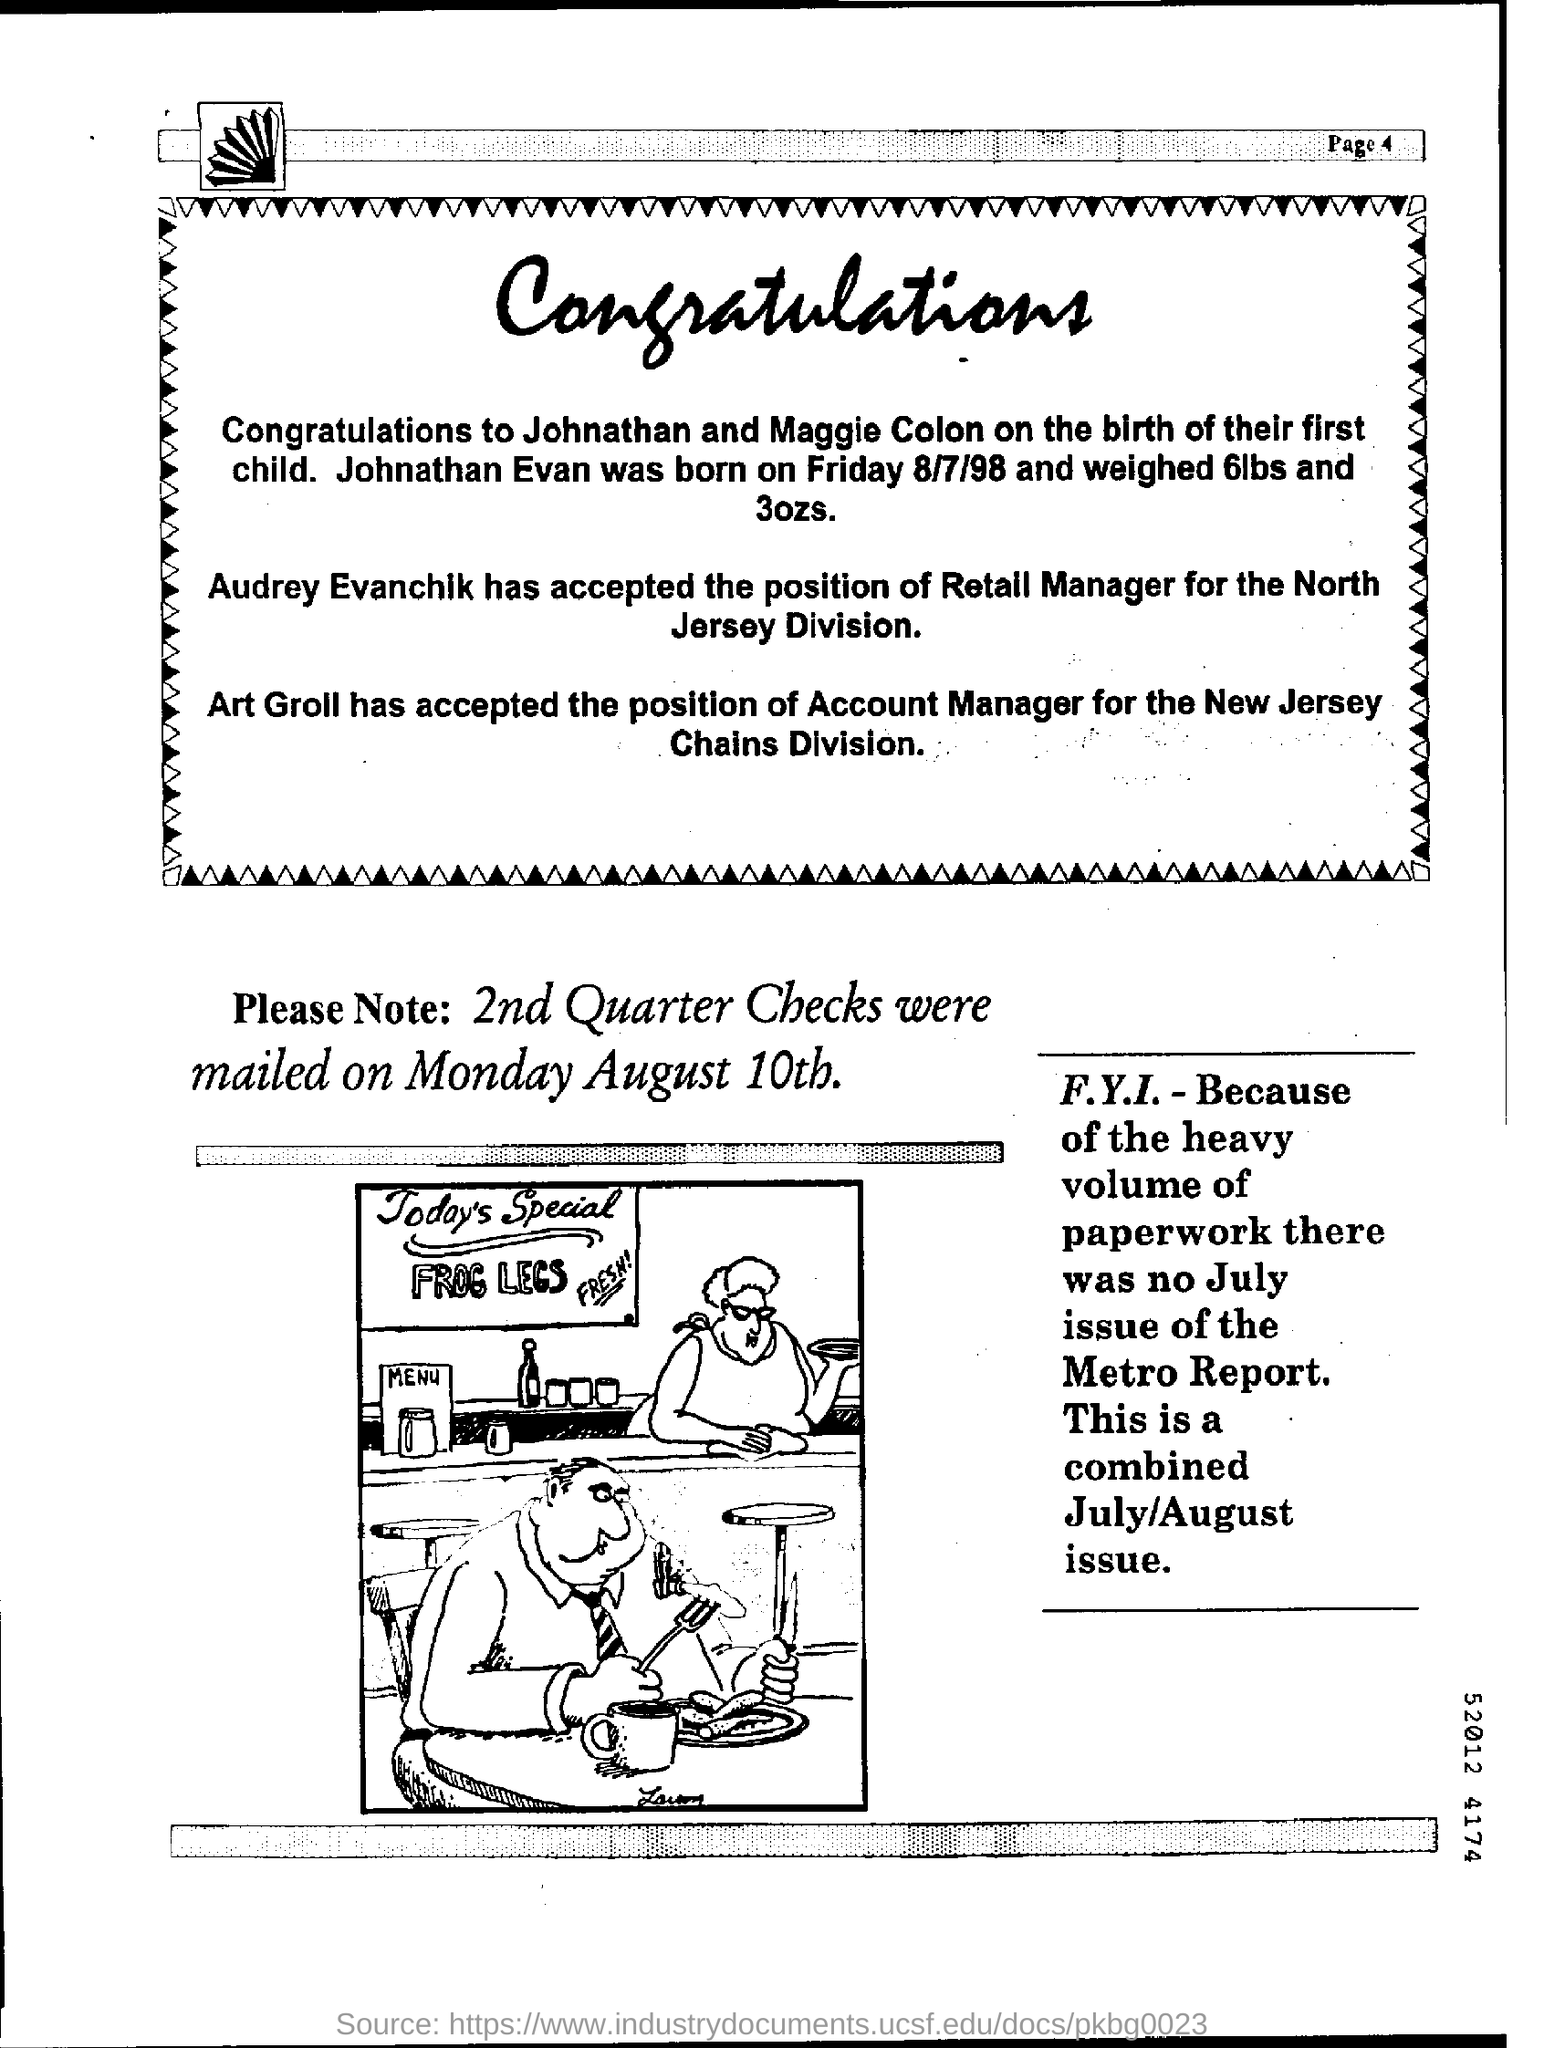WHEN WAS THE 2ND QUARTER CHECKS MAILED?
Provide a succinct answer. MONDAY AUGUST 10th. WHEN WAS JOHNATHAN EVAN BORN?
Give a very brief answer. FRIDAY 8/7/98. HOW MUCH DID JOHNATHAN EVAN WEIGH?
Keep it short and to the point. 6lbs and 3Ozs. WHO ARE THE PARENTS OF JOHNATHAN EVAN?
Give a very brief answer. Johnathan and Maggie Colon. WHO HAS ACCEPTED THE POSITION OF RETAIL MANAGER FOR THE NORTH JERSEY DIVISION?
Provide a succinct answer. Audrey Evanchik. WHAT POSITION HAS ART GROLL ACCEPTED?
Ensure brevity in your answer.  Account Manager. ART GROLL HAS ACCEPTED THE POSITION OF ACCOUNT MANAGER FOR WHICH DIVISION?
Ensure brevity in your answer.  CHAINS DIVISION. 